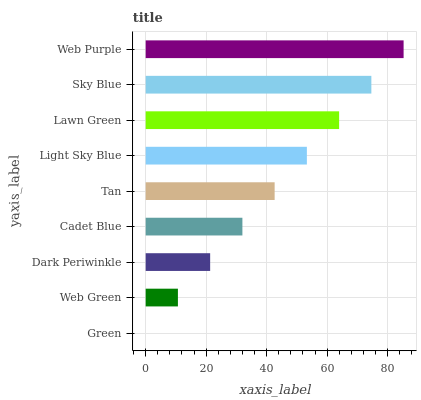Is Green the minimum?
Answer yes or no. Yes. Is Web Purple the maximum?
Answer yes or no. Yes. Is Web Green the minimum?
Answer yes or no. No. Is Web Green the maximum?
Answer yes or no. No. Is Web Green greater than Green?
Answer yes or no. Yes. Is Green less than Web Green?
Answer yes or no. Yes. Is Green greater than Web Green?
Answer yes or no. No. Is Web Green less than Green?
Answer yes or no. No. Is Tan the high median?
Answer yes or no. Yes. Is Tan the low median?
Answer yes or no. Yes. Is Cadet Blue the high median?
Answer yes or no. No. Is Green the low median?
Answer yes or no. No. 